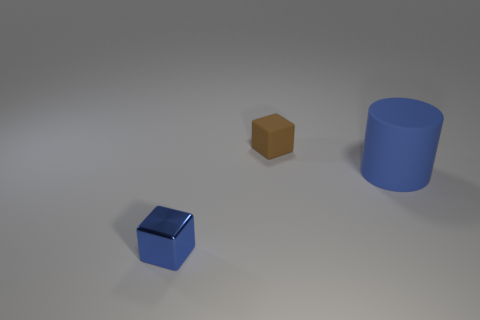How many other objects are the same shape as the blue shiny object?
Ensure brevity in your answer.  1. What shape is the small shiny thing?
Make the answer very short. Cube. Is the material of the blue cylinder the same as the small brown thing?
Give a very brief answer. Yes. Are there the same number of brown matte blocks that are to the left of the blue metal thing and blue blocks behind the rubber cube?
Your answer should be compact. Yes. There is a matte thing that is to the right of the tiny block behind the tiny blue block; are there any blocks right of it?
Provide a succinct answer. No. Do the rubber cube and the metallic object have the same size?
Offer a terse response. Yes. There is a small thing to the left of the small thing that is on the right side of the small cube in front of the tiny matte thing; what is its color?
Ensure brevity in your answer.  Blue. How many matte things have the same color as the cylinder?
Ensure brevity in your answer.  0. How many tiny objects are either red shiny spheres or blue metal things?
Ensure brevity in your answer.  1. Is there another small blue thing that has the same shape as the small blue shiny object?
Your answer should be compact. No. 